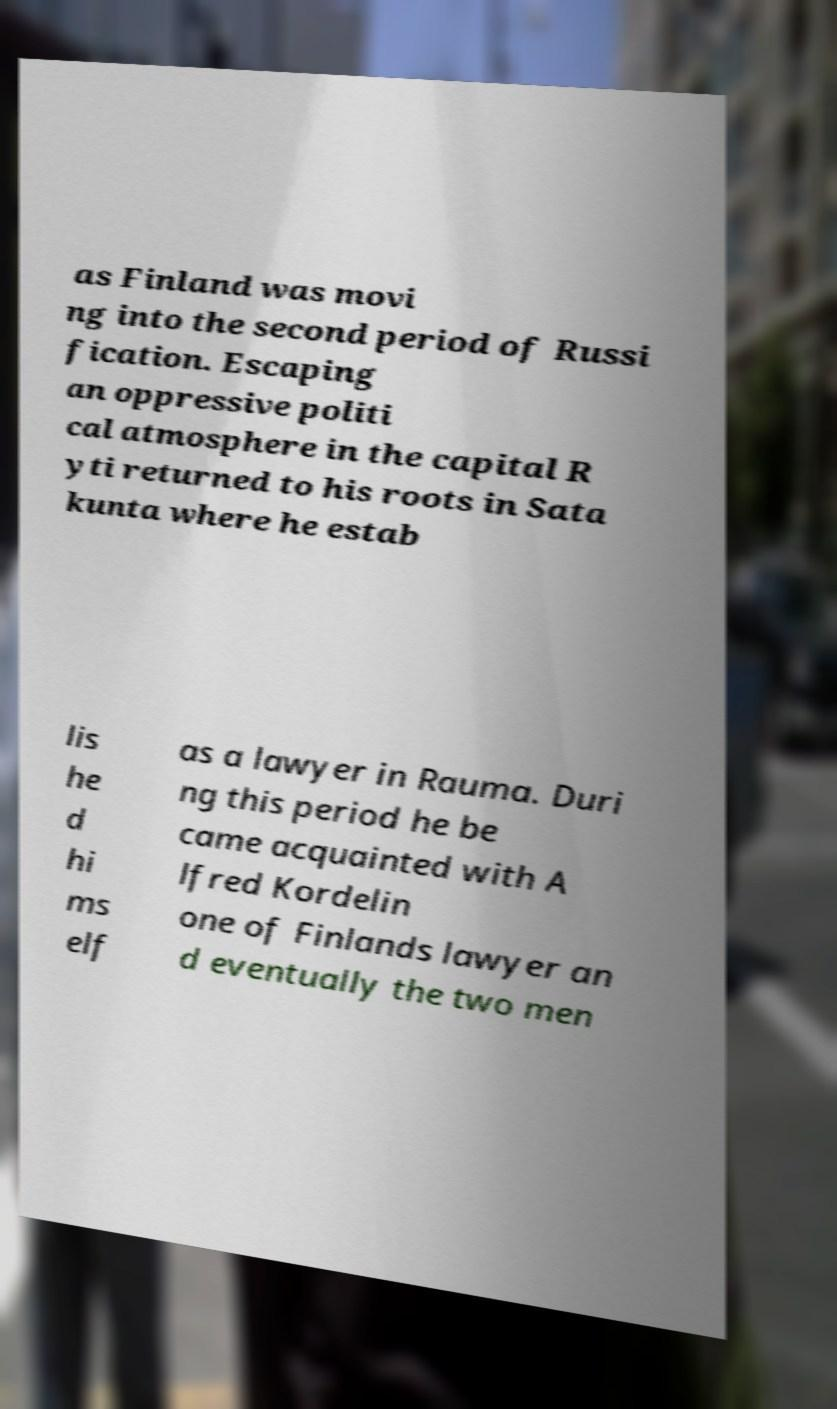What messages or text are displayed in this image? I need them in a readable, typed format. as Finland was movi ng into the second period of Russi fication. Escaping an oppressive politi cal atmosphere in the capital R yti returned to his roots in Sata kunta where he estab lis he d hi ms elf as a lawyer in Rauma. Duri ng this period he be came acquainted with A lfred Kordelin one of Finlands lawyer an d eventually the two men 